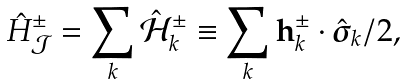<formula> <loc_0><loc_0><loc_500><loc_500>\hat { H } ^ { \pm } _ { \mathcal { J } } = \sum _ { k } \hat { \mathcal { H } } ^ { \pm } _ { k } \equiv \sum _ { k } { \mathbf h } _ { k } ^ { \pm } \cdot \hat { \boldsymbol \sigma } _ { k } / 2 ,</formula> 